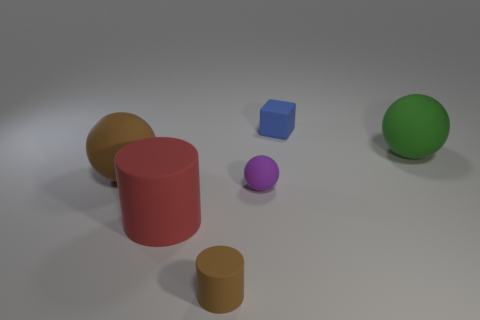Add 2 blue objects. How many objects exist? 8 Subtract all blocks. How many objects are left? 5 Subtract all red cylinders. Subtract all purple balls. How many objects are left? 4 Add 6 large red cylinders. How many large red cylinders are left? 7 Add 1 tiny rubber balls. How many tiny rubber balls exist? 2 Subtract 0 green cubes. How many objects are left? 6 